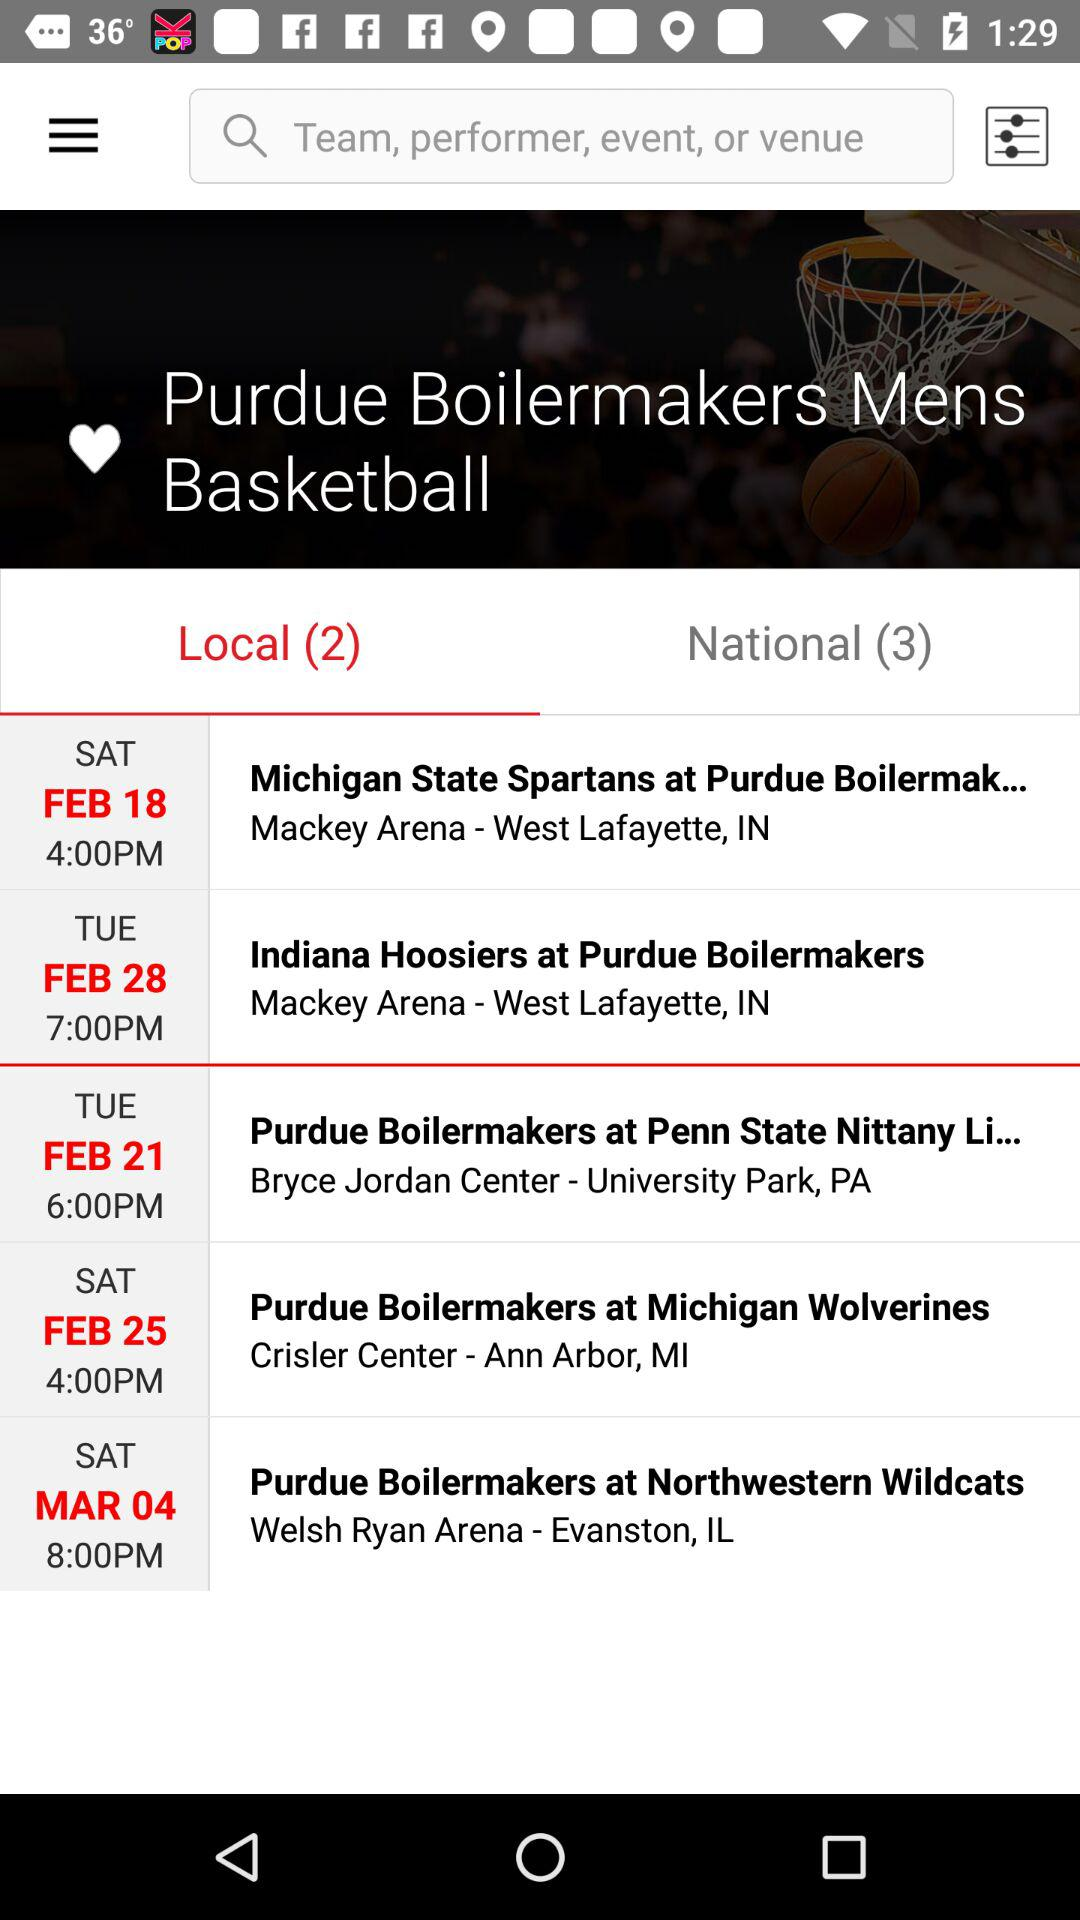What day is March 4? The day is Saturday. 